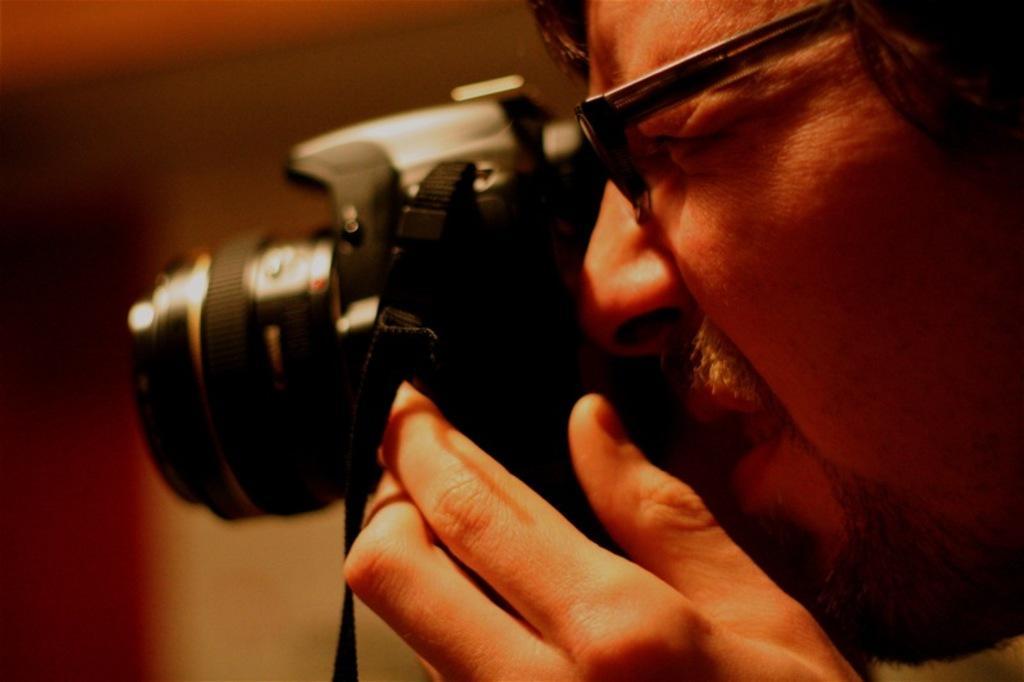Please provide a concise description of this image. In this image a man is holding a camera in his hand and ready to click a picture. He is wearing the spectacles. 